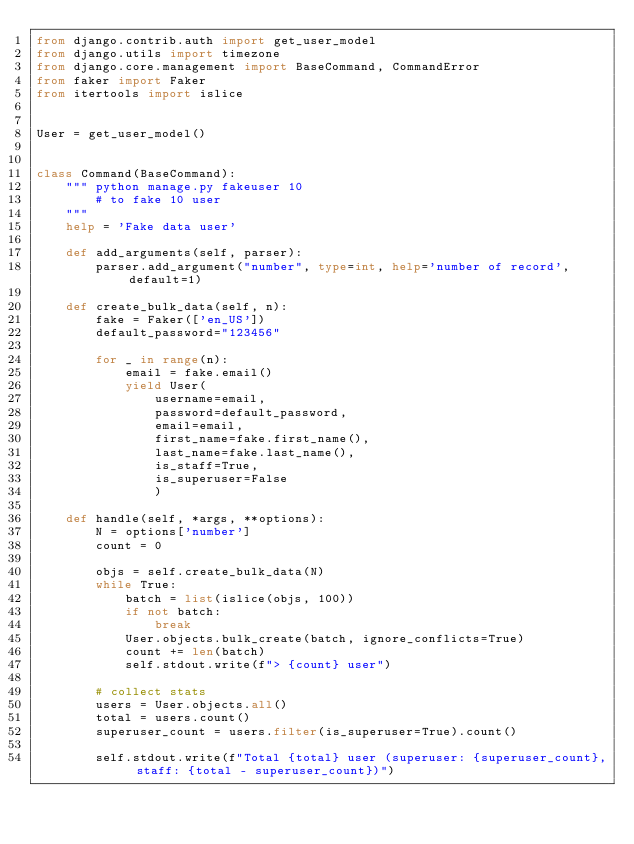<code> <loc_0><loc_0><loc_500><loc_500><_Python_>from django.contrib.auth import get_user_model
from django.utils import timezone
from django.core.management import BaseCommand, CommandError
from faker import Faker
from itertools import islice


User = get_user_model()


class Command(BaseCommand):
    """ python manage.py fakeuser 10
        # to fake 10 user
    """
    help = 'Fake data user'

    def add_arguments(self, parser):
        parser.add_argument("number", type=int, help='number of record', default=1)

    def create_bulk_data(self, n):
        fake = Faker(['en_US'])
        default_password="123456"

        for _ in range(n):
            email = fake.email()
            yield User(
                username=email,
                password=default_password,
                email=email,
                first_name=fake.first_name(),
                last_name=fake.last_name(),
                is_staff=True,
                is_superuser=False
                )

    def handle(self, *args, **options):
        N = options['number']
        count = 0

        objs = self.create_bulk_data(N)
        while True:
            batch = list(islice(objs, 100))
            if not batch:
                break
            User.objects.bulk_create(batch, ignore_conflicts=True)
            count += len(batch)
            self.stdout.write(f"> {count} user")

        # collect stats
        users = User.objects.all()
        total = users.count()
        superuser_count = users.filter(is_superuser=True).count()

        self.stdout.write(f"Total {total} user (superuser: {superuser_count}, staff: {total - superuser_count})")
</code> 